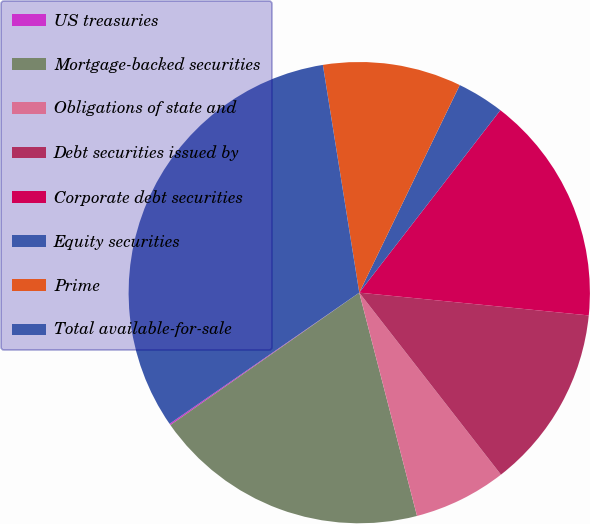Convert chart. <chart><loc_0><loc_0><loc_500><loc_500><pie_chart><fcel>US treasuries<fcel>Mortgage-backed securities<fcel>Obligations of state and<fcel>Debt securities issued by<fcel>Corporate debt securities<fcel>Equity securities<fcel>Prime<fcel>Total available-for-sale<nl><fcel>0.1%<fcel>19.3%<fcel>6.5%<fcel>12.9%<fcel>16.1%<fcel>3.3%<fcel>9.7%<fcel>32.11%<nl></chart> 